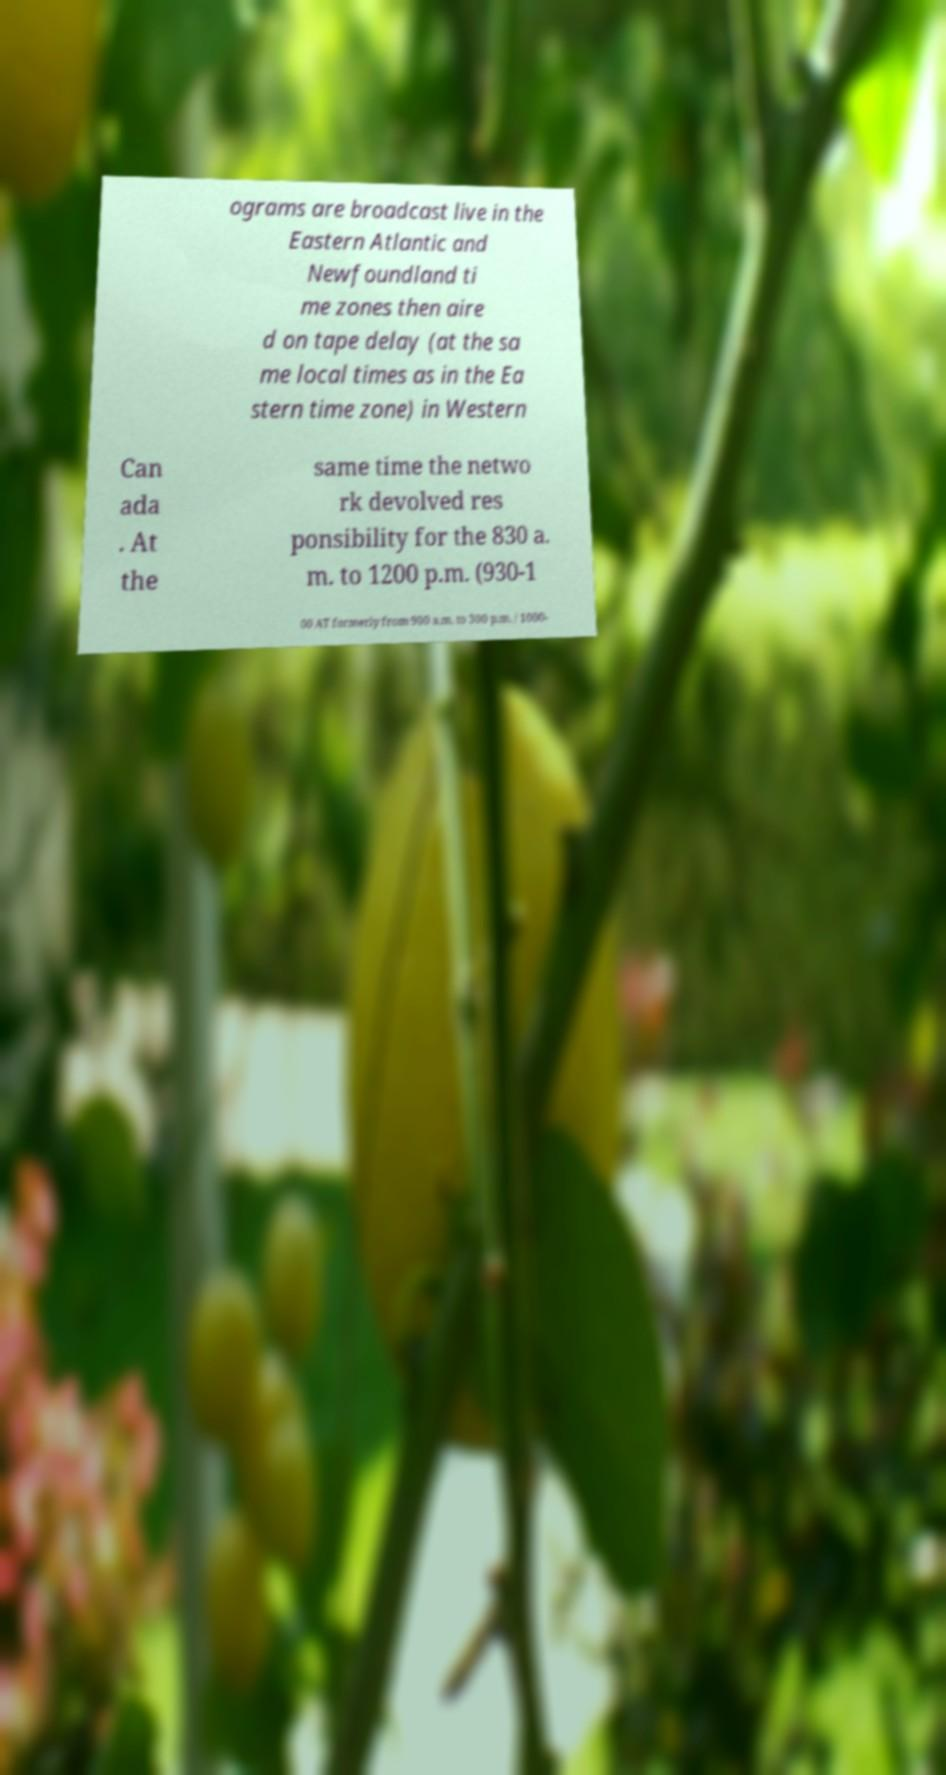Please identify and transcribe the text found in this image. ograms are broadcast live in the Eastern Atlantic and Newfoundland ti me zones then aire d on tape delay (at the sa me local times as in the Ea stern time zone) in Western Can ada . At the same time the netwo rk devolved res ponsibility for the 830 a. m. to 1200 p.m. (930-1 00 AT formerly from 900 a.m. to 300 p.m. / 1000- 